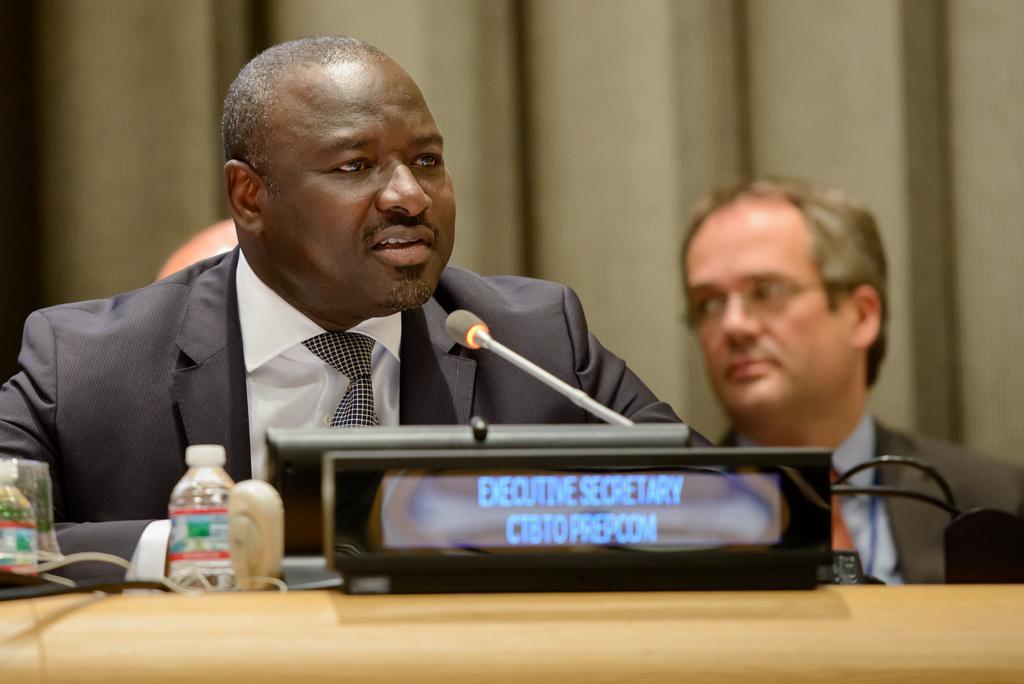How would you summarize this image in a sentence or two? In this picture there is a person talking. There is a microphone and there are bottles and there is a device and there are wires on the table. At the back there is a person and there is a curtain. 